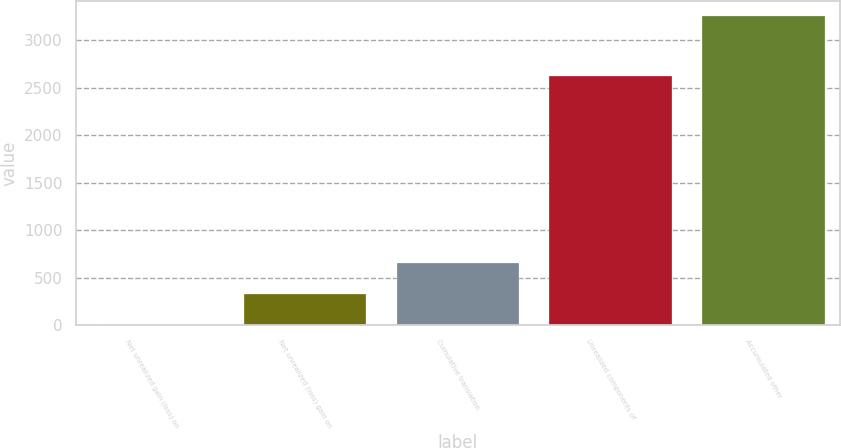<chart> <loc_0><loc_0><loc_500><loc_500><bar_chart><fcel>Net unrealized gain (loss) on<fcel>Net unrealized (loss) gain on<fcel>Cumulative translation<fcel>Unrealized components of<fcel>Accumulated other<nl><fcel>4<fcel>328.3<fcel>652.6<fcel>2623<fcel>3247<nl></chart> 